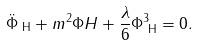Convert formula to latex. <formula><loc_0><loc_0><loc_500><loc_500>\ddot { \Phi } _ { \text { H} } + m ^ { 2 } \Phi H + \frac { \lambda } { 6 } \Phi ^ { 3 } _ { \text { H} } = 0 .</formula> 